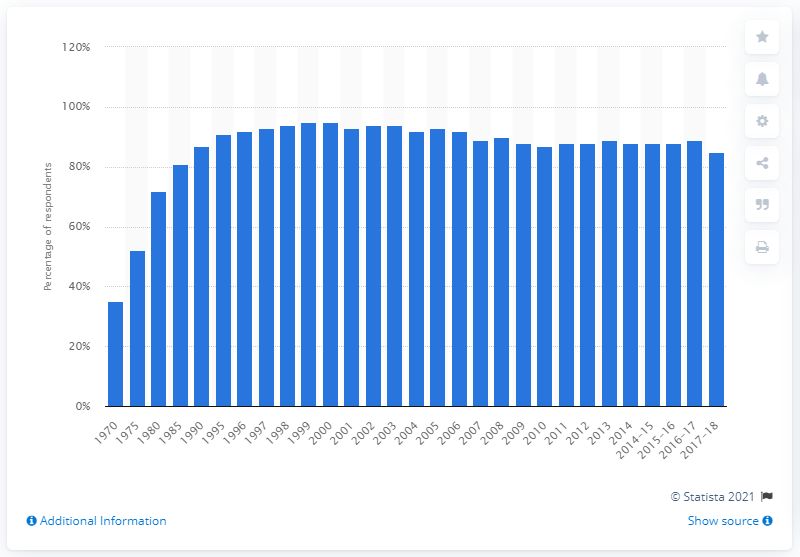Identify some key points in this picture. Fixed-line telephony lost customers in 1998. In 2018, 85% of households owned a landline telephone. The market penetration in 1998-2000 was 95%. 